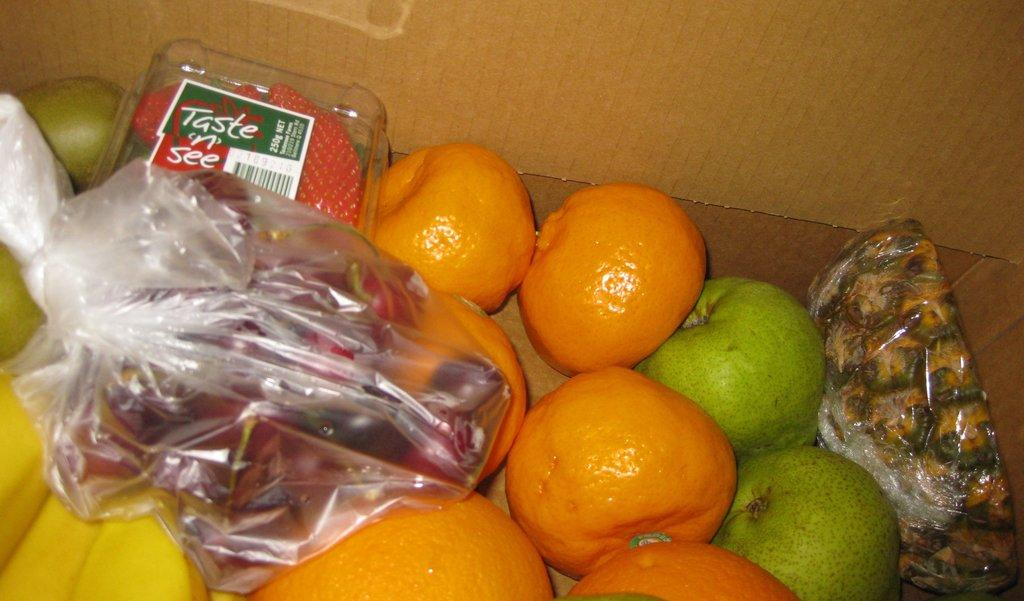What type of container is present in the image? There is a carton box in the image. What fruits are inside the carton box? The carton box contains oranges, guavas, bananas, pears, and dates. What other type of container is present in the image? There is a plastic cover containing grapes and a box containing strawberries in the image. What type of quiver is visible in the image? There is no quiver present in the image. How do the strawberries stretch in the box? The strawberries do not stretch in the box; they are stationary fruits. 